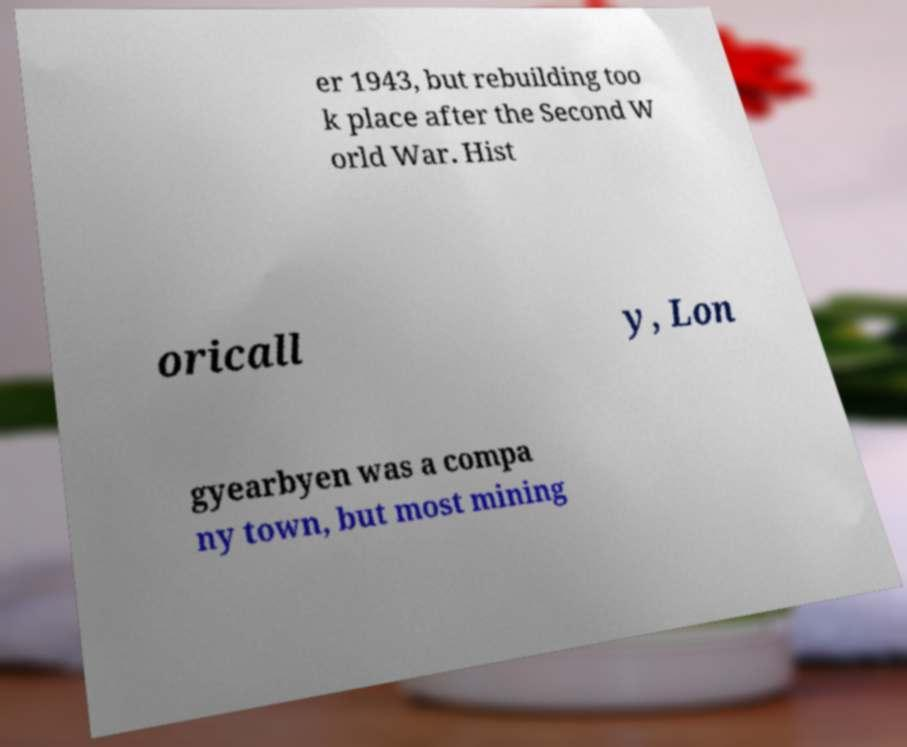There's text embedded in this image that I need extracted. Can you transcribe it verbatim? er 1943, but rebuilding too k place after the Second W orld War. Hist oricall y, Lon gyearbyen was a compa ny town, but most mining 